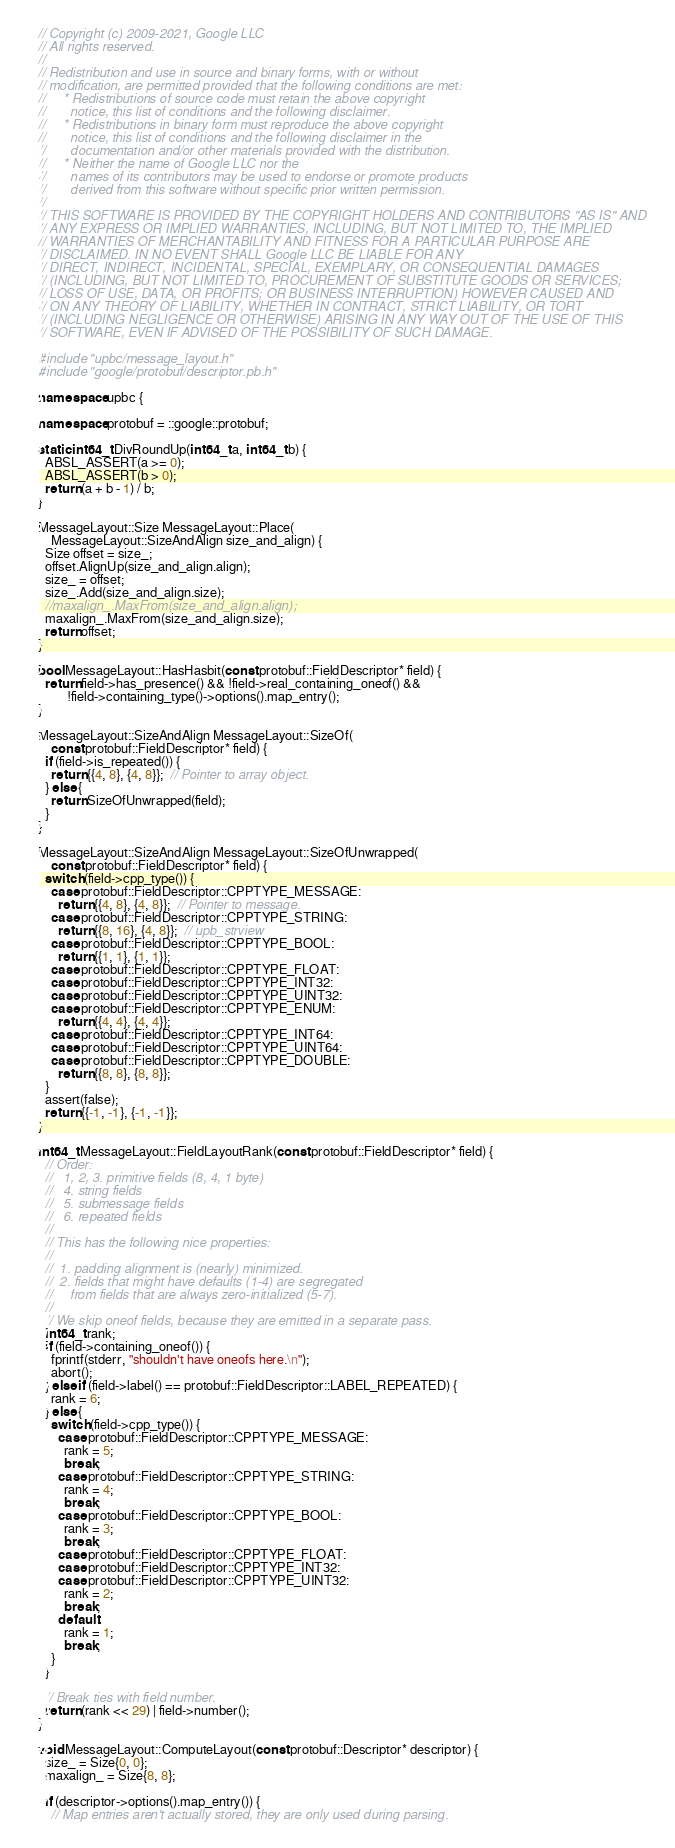Convert code to text. <code><loc_0><loc_0><loc_500><loc_500><_C++_>// Copyright (c) 2009-2021, Google LLC
// All rights reserved.
//
// Redistribution and use in source and binary forms, with or without
// modification, are permitted provided that the following conditions are met:
//     * Redistributions of source code must retain the above copyright
//       notice, this list of conditions and the following disclaimer.
//     * Redistributions in binary form must reproduce the above copyright
//       notice, this list of conditions and the following disclaimer in the
//       documentation and/or other materials provided with the distribution.
//     * Neither the name of Google LLC nor the
//       names of its contributors may be used to endorse or promote products
//       derived from this software without specific prior written permission.
//
// THIS SOFTWARE IS PROVIDED BY THE COPYRIGHT HOLDERS AND CONTRIBUTORS "AS IS" AND
// ANY EXPRESS OR IMPLIED WARRANTIES, INCLUDING, BUT NOT LIMITED TO, THE IMPLIED
// WARRANTIES OF MERCHANTABILITY AND FITNESS FOR A PARTICULAR PURPOSE ARE
// DISCLAIMED. IN NO EVENT SHALL Google LLC BE LIABLE FOR ANY
// DIRECT, INDIRECT, INCIDENTAL, SPECIAL, EXEMPLARY, OR CONSEQUENTIAL DAMAGES
// (INCLUDING, BUT NOT LIMITED TO, PROCUREMENT OF SUBSTITUTE GOODS OR SERVICES;
// LOSS OF USE, DATA, OR PROFITS; OR BUSINESS INTERRUPTION) HOWEVER CAUSED AND
// ON ANY THEORY OF LIABILITY, WHETHER IN CONTRACT, STRICT LIABILITY, OR TORT
// (INCLUDING NEGLIGENCE OR OTHERWISE) ARISING IN ANY WAY OUT OF THE USE OF THIS
// SOFTWARE, EVEN IF ADVISED OF THE POSSIBILITY OF SUCH DAMAGE.

#include "upbc/message_layout.h"
#include "google/protobuf/descriptor.pb.h"

namespace upbc {

namespace protobuf = ::google::protobuf;

static int64_t DivRoundUp(int64_t a, int64_t b) {
  ABSL_ASSERT(a >= 0);
  ABSL_ASSERT(b > 0);
  return (a + b - 1) / b;
}

MessageLayout::Size MessageLayout::Place(
    MessageLayout::SizeAndAlign size_and_align) {
  Size offset = size_;
  offset.AlignUp(size_and_align.align);
  size_ = offset;
  size_.Add(size_and_align.size);
  //maxalign_.MaxFrom(size_and_align.align);
  maxalign_.MaxFrom(size_and_align.size);
  return offset;
}

bool MessageLayout::HasHasbit(const protobuf::FieldDescriptor* field) {
  return field->has_presence() && !field->real_containing_oneof() &&
         !field->containing_type()->options().map_entry();
}

MessageLayout::SizeAndAlign MessageLayout::SizeOf(
    const protobuf::FieldDescriptor* field) {
  if (field->is_repeated()) {
    return {{4, 8}, {4, 8}};  // Pointer to array object.
  } else {
    return SizeOfUnwrapped(field);
  }
}

MessageLayout::SizeAndAlign MessageLayout::SizeOfUnwrapped(
    const protobuf::FieldDescriptor* field) {
  switch (field->cpp_type()) {
    case protobuf::FieldDescriptor::CPPTYPE_MESSAGE:
      return {{4, 8}, {4, 8}};  // Pointer to message.
    case protobuf::FieldDescriptor::CPPTYPE_STRING:
      return {{8, 16}, {4, 8}};  // upb_strview
    case protobuf::FieldDescriptor::CPPTYPE_BOOL:
      return {{1, 1}, {1, 1}};
    case protobuf::FieldDescriptor::CPPTYPE_FLOAT:
    case protobuf::FieldDescriptor::CPPTYPE_INT32:
    case protobuf::FieldDescriptor::CPPTYPE_UINT32:
    case protobuf::FieldDescriptor::CPPTYPE_ENUM:
      return {{4, 4}, {4, 4}};
    case protobuf::FieldDescriptor::CPPTYPE_INT64:
    case protobuf::FieldDescriptor::CPPTYPE_UINT64:
    case protobuf::FieldDescriptor::CPPTYPE_DOUBLE:
      return {{8, 8}, {8, 8}};
  }
  assert(false);
  return {{-1, -1}, {-1, -1}};
}

int64_t MessageLayout::FieldLayoutRank(const protobuf::FieldDescriptor* field) {
  // Order:
  //   1, 2, 3. primitive fields (8, 4, 1 byte)
  //   4. string fields
  //   5. submessage fields
  //   6. repeated fields
  //
  // This has the following nice properties:
  //
  //  1. padding alignment is (nearly) minimized.
  //  2. fields that might have defaults (1-4) are segregated
  //     from fields that are always zero-initialized (5-7).
  //
  // We skip oneof fields, because they are emitted in a separate pass.
  int64_t rank;
  if (field->containing_oneof()) {
    fprintf(stderr, "shouldn't have oneofs here.\n");
    abort();
  } else if (field->label() == protobuf::FieldDescriptor::LABEL_REPEATED) {
    rank = 6;
  } else {
    switch (field->cpp_type()) {
      case protobuf::FieldDescriptor::CPPTYPE_MESSAGE:
        rank = 5;
        break;
      case protobuf::FieldDescriptor::CPPTYPE_STRING:
        rank = 4;
        break;
      case protobuf::FieldDescriptor::CPPTYPE_BOOL:
        rank = 3;
        break;
      case protobuf::FieldDescriptor::CPPTYPE_FLOAT:
      case protobuf::FieldDescriptor::CPPTYPE_INT32:
      case protobuf::FieldDescriptor::CPPTYPE_UINT32:
        rank = 2;
        break;
      default:
        rank = 1;
        break;
    }
  }

  // Break ties with field number.
  return (rank << 29) | field->number();
}

void MessageLayout::ComputeLayout(const protobuf::Descriptor* descriptor) {
  size_ = Size{0, 0};
  maxalign_ = Size{8, 8};

  if (descriptor->options().map_entry()) {
    // Map entries aren't actually stored, they are only used during parsing.</code> 